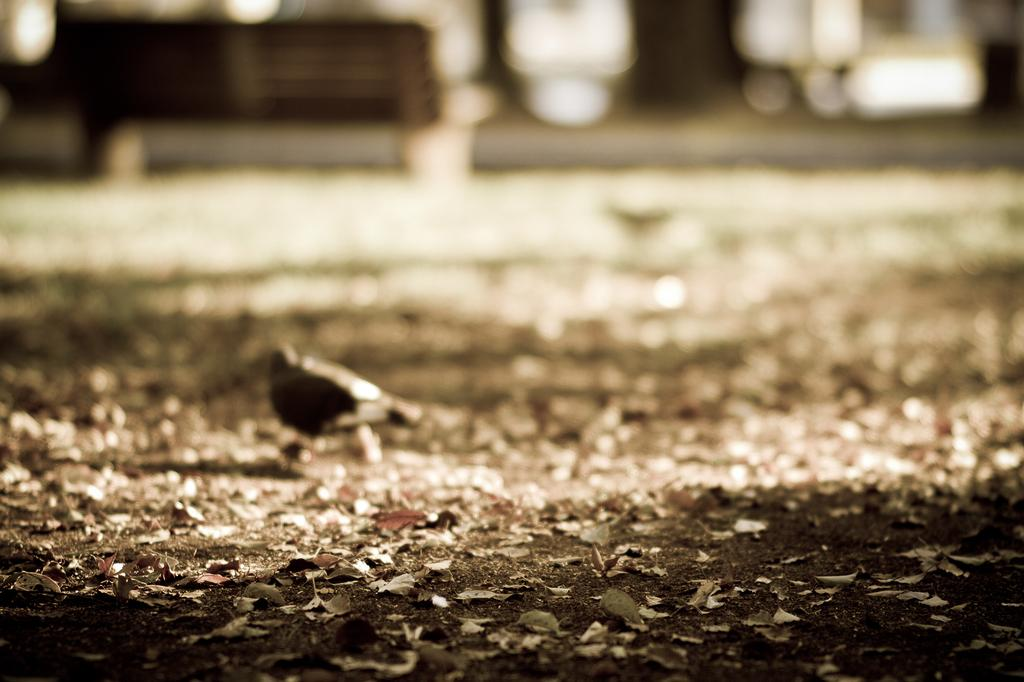What is on the ground in the image? There is a bird and dry leaves on the ground. Can you describe the bird in the image? The bird is on the ground, but there is no information about its species or appearance. What is the condition of the ground in the image? The ground has dry leaves on it. How would you describe the background of the image? The background of the image is blurred. What type of copper key can be seen in the image? There is no copper key present in the image. 